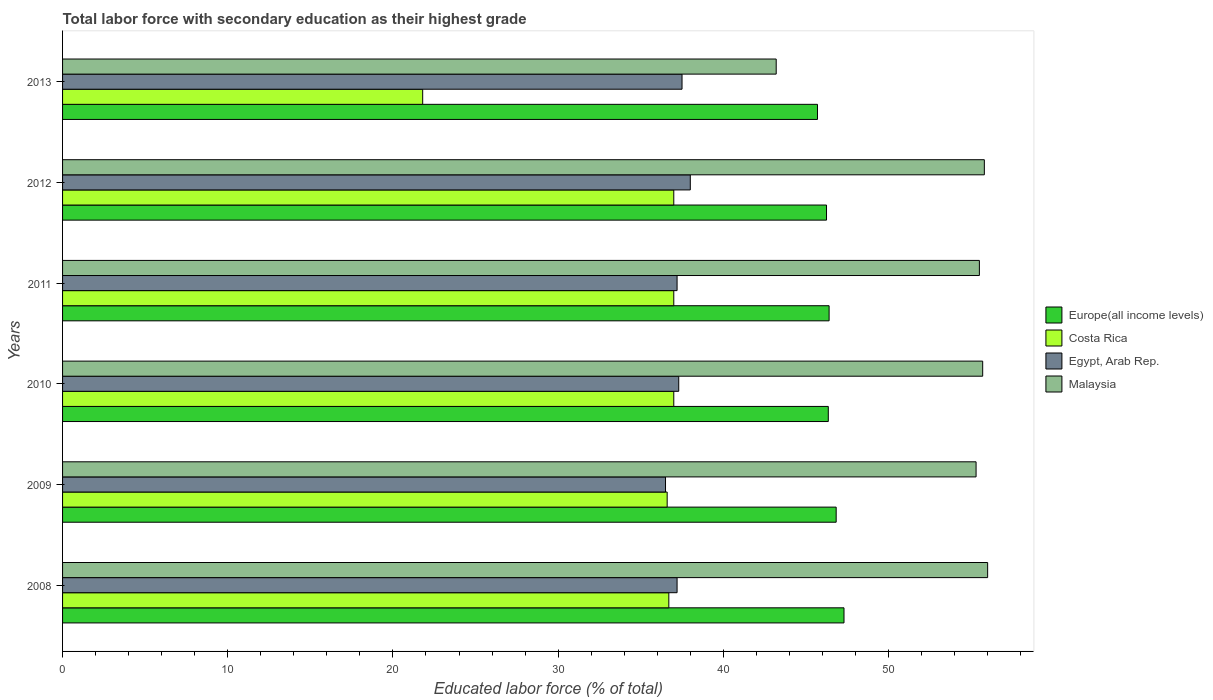How many groups of bars are there?
Your response must be concise. 6. Are the number of bars per tick equal to the number of legend labels?
Ensure brevity in your answer.  Yes. How many bars are there on the 4th tick from the top?
Your answer should be compact. 4. In how many cases, is the number of bars for a given year not equal to the number of legend labels?
Your response must be concise. 0. What is the percentage of total labor force with primary education in Egypt, Arab Rep. in 2011?
Offer a terse response. 37.2. Across all years, what is the maximum percentage of total labor force with primary education in Europe(all income levels)?
Provide a short and direct response. 47.3. Across all years, what is the minimum percentage of total labor force with primary education in Egypt, Arab Rep.?
Offer a terse response. 36.5. In which year was the percentage of total labor force with primary education in Egypt, Arab Rep. maximum?
Your answer should be very brief. 2012. In which year was the percentage of total labor force with primary education in Egypt, Arab Rep. minimum?
Your response must be concise. 2009. What is the total percentage of total labor force with primary education in Malaysia in the graph?
Offer a very short reply. 321.5. What is the difference between the percentage of total labor force with primary education in Malaysia in 2009 and the percentage of total labor force with primary education in Egypt, Arab Rep. in 2011?
Provide a succinct answer. 18.1. What is the average percentage of total labor force with primary education in Costa Rica per year?
Your response must be concise. 34.35. In the year 2010, what is the difference between the percentage of total labor force with primary education in Europe(all income levels) and percentage of total labor force with primary education in Costa Rica?
Offer a very short reply. 9.35. What is the ratio of the percentage of total labor force with primary education in Malaysia in 2008 to that in 2012?
Ensure brevity in your answer.  1. What is the difference between the highest and the second highest percentage of total labor force with primary education in Malaysia?
Your answer should be very brief. 0.2. What is the difference between the highest and the lowest percentage of total labor force with primary education in Europe(all income levels)?
Your answer should be compact. 1.61. Is the sum of the percentage of total labor force with primary education in Malaysia in 2008 and 2011 greater than the maximum percentage of total labor force with primary education in Europe(all income levels) across all years?
Keep it short and to the point. Yes. Is it the case that in every year, the sum of the percentage of total labor force with primary education in Costa Rica and percentage of total labor force with primary education in Malaysia is greater than the sum of percentage of total labor force with primary education in Egypt, Arab Rep. and percentage of total labor force with primary education in Europe(all income levels)?
Make the answer very short. No. What does the 2nd bar from the top in 2013 represents?
Your answer should be compact. Egypt, Arab Rep. What does the 4th bar from the bottom in 2010 represents?
Offer a very short reply. Malaysia. Is it the case that in every year, the sum of the percentage of total labor force with primary education in Malaysia and percentage of total labor force with primary education in Europe(all income levels) is greater than the percentage of total labor force with primary education in Egypt, Arab Rep.?
Your response must be concise. Yes. Are all the bars in the graph horizontal?
Offer a terse response. Yes. Does the graph contain any zero values?
Give a very brief answer. No. Does the graph contain grids?
Your answer should be compact. No. Where does the legend appear in the graph?
Offer a very short reply. Center right. How are the legend labels stacked?
Give a very brief answer. Vertical. What is the title of the graph?
Offer a terse response. Total labor force with secondary education as their highest grade. What is the label or title of the X-axis?
Provide a short and direct response. Educated labor force (% of total). What is the Educated labor force (% of total) in Europe(all income levels) in 2008?
Provide a short and direct response. 47.3. What is the Educated labor force (% of total) in Costa Rica in 2008?
Provide a short and direct response. 36.7. What is the Educated labor force (% of total) in Egypt, Arab Rep. in 2008?
Your response must be concise. 37.2. What is the Educated labor force (% of total) in Europe(all income levels) in 2009?
Your response must be concise. 46.83. What is the Educated labor force (% of total) of Costa Rica in 2009?
Offer a terse response. 36.6. What is the Educated labor force (% of total) of Egypt, Arab Rep. in 2009?
Offer a very short reply. 36.5. What is the Educated labor force (% of total) in Malaysia in 2009?
Your answer should be compact. 55.3. What is the Educated labor force (% of total) in Europe(all income levels) in 2010?
Keep it short and to the point. 46.35. What is the Educated labor force (% of total) of Egypt, Arab Rep. in 2010?
Your answer should be very brief. 37.3. What is the Educated labor force (% of total) of Malaysia in 2010?
Keep it short and to the point. 55.7. What is the Educated labor force (% of total) of Europe(all income levels) in 2011?
Offer a very short reply. 46.4. What is the Educated labor force (% of total) in Costa Rica in 2011?
Offer a terse response. 37. What is the Educated labor force (% of total) of Egypt, Arab Rep. in 2011?
Keep it short and to the point. 37.2. What is the Educated labor force (% of total) in Malaysia in 2011?
Ensure brevity in your answer.  55.5. What is the Educated labor force (% of total) of Europe(all income levels) in 2012?
Provide a short and direct response. 46.25. What is the Educated labor force (% of total) in Egypt, Arab Rep. in 2012?
Your response must be concise. 38. What is the Educated labor force (% of total) of Malaysia in 2012?
Offer a very short reply. 55.8. What is the Educated labor force (% of total) in Europe(all income levels) in 2013?
Give a very brief answer. 45.7. What is the Educated labor force (% of total) of Costa Rica in 2013?
Offer a very short reply. 21.8. What is the Educated labor force (% of total) of Egypt, Arab Rep. in 2013?
Ensure brevity in your answer.  37.5. What is the Educated labor force (% of total) of Malaysia in 2013?
Ensure brevity in your answer.  43.2. Across all years, what is the maximum Educated labor force (% of total) of Europe(all income levels)?
Give a very brief answer. 47.3. Across all years, what is the maximum Educated labor force (% of total) in Costa Rica?
Ensure brevity in your answer.  37. Across all years, what is the maximum Educated labor force (% of total) of Malaysia?
Provide a succinct answer. 56. Across all years, what is the minimum Educated labor force (% of total) in Europe(all income levels)?
Your answer should be compact. 45.7. Across all years, what is the minimum Educated labor force (% of total) in Costa Rica?
Provide a short and direct response. 21.8. Across all years, what is the minimum Educated labor force (% of total) in Egypt, Arab Rep.?
Ensure brevity in your answer.  36.5. Across all years, what is the minimum Educated labor force (% of total) of Malaysia?
Ensure brevity in your answer.  43.2. What is the total Educated labor force (% of total) of Europe(all income levels) in the graph?
Provide a succinct answer. 278.84. What is the total Educated labor force (% of total) in Costa Rica in the graph?
Ensure brevity in your answer.  206.1. What is the total Educated labor force (% of total) of Egypt, Arab Rep. in the graph?
Keep it short and to the point. 223.7. What is the total Educated labor force (% of total) of Malaysia in the graph?
Provide a succinct answer. 321.5. What is the difference between the Educated labor force (% of total) of Europe(all income levels) in 2008 and that in 2009?
Provide a succinct answer. 0.47. What is the difference between the Educated labor force (% of total) of Egypt, Arab Rep. in 2008 and that in 2009?
Ensure brevity in your answer.  0.7. What is the difference between the Educated labor force (% of total) of Europe(all income levels) in 2008 and that in 2010?
Give a very brief answer. 0.95. What is the difference between the Educated labor force (% of total) in Malaysia in 2008 and that in 2010?
Keep it short and to the point. 0.3. What is the difference between the Educated labor force (% of total) of Europe(all income levels) in 2008 and that in 2011?
Your response must be concise. 0.9. What is the difference between the Educated labor force (% of total) of Costa Rica in 2008 and that in 2011?
Your response must be concise. -0.3. What is the difference between the Educated labor force (% of total) in Malaysia in 2008 and that in 2011?
Offer a very short reply. 0.5. What is the difference between the Educated labor force (% of total) in Europe(all income levels) in 2008 and that in 2012?
Ensure brevity in your answer.  1.06. What is the difference between the Educated labor force (% of total) in Egypt, Arab Rep. in 2008 and that in 2012?
Offer a very short reply. -0.8. What is the difference between the Educated labor force (% of total) in Malaysia in 2008 and that in 2012?
Your answer should be compact. 0.2. What is the difference between the Educated labor force (% of total) in Europe(all income levels) in 2008 and that in 2013?
Your answer should be compact. 1.61. What is the difference between the Educated labor force (% of total) in Costa Rica in 2008 and that in 2013?
Offer a terse response. 14.9. What is the difference between the Educated labor force (% of total) of Europe(all income levels) in 2009 and that in 2010?
Ensure brevity in your answer.  0.48. What is the difference between the Educated labor force (% of total) in Europe(all income levels) in 2009 and that in 2011?
Keep it short and to the point. 0.43. What is the difference between the Educated labor force (% of total) of Costa Rica in 2009 and that in 2011?
Provide a short and direct response. -0.4. What is the difference between the Educated labor force (% of total) of Egypt, Arab Rep. in 2009 and that in 2011?
Provide a short and direct response. -0.7. What is the difference between the Educated labor force (% of total) of Europe(all income levels) in 2009 and that in 2012?
Make the answer very short. 0.58. What is the difference between the Educated labor force (% of total) of Costa Rica in 2009 and that in 2012?
Your answer should be compact. -0.4. What is the difference between the Educated labor force (% of total) in Egypt, Arab Rep. in 2009 and that in 2012?
Ensure brevity in your answer.  -1.5. What is the difference between the Educated labor force (% of total) in Europe(all income levels) in 2009 and that in 2013?
Keep it short and to the point. 1.13. What is the difference between the Educated labor force (% of total) in Europe(all income levels) in 2010 and that in 2011?
Give a very brief answer. -0.05. What is the difference between the Educated labor force (% of total) of Egypt, Arab Rep. in 2010 and that in 2011?
Provide a short and direct response. 0.1. What is the difference between the Educated labor force (% of total) of Europe(all income levels) in 2010 and that in 2012?
Ensure brevity in your answer.  0.11. What is the difference between the Educated labor force (% of total) in Costa Rica in 2010 and that in 2012?
Ensure brevity in your answer.  0. What is the difference between the Educated labor force (% of total) of Malaysia in 2010 and that in 2012?
Provide a succinct answer. -0.1. What is the difference between the Educated labor force (% of total) in Europe(all income levels) in 2010 and that in 2013?
Provide a short and direct response. 0.65. What is the difference between the Educated labor force (% of total) in Malaysia in 2010 and that in 2013?
Your answer should be compact. 12.5. What is the difference between the Educated labor force (% of total) of Europe(all income levels) in 2011 and that in 2012?
Provide a succinct answer. 0.16. What is the difference between the Educated labor force (% of total) in Egypt, Arab Rep. in 2011 and that in 2012?
Make the answer very short. -0.8. What is the difference between the Educated labor force (% of total) of Malaysia in 2011 and that in 2012?
Provide a succinct answer. -0.3. What is the difference between the Educated labor force (% of total) of Europe(all income levels) in 2011 and that in 2013?
Provide a short and direct response. 0.7. What is the difference between the Educated labor force (% of total) in Egypt, Arab Rep. in 2011 and that in 2013?
Offer a very short reply. -0.3. What is the difference between the Educated labor force (% of total) in Malaysia in 2011 and that in 2013?
Offer a very short reply. 12.3. What is the difference between the Educated labor force (% of total) in Europe(all income levels) in 2012 and that in 2013?
Give a very brief answer. 0.55. What is the difference between the Educated labor force (% of total) of Europe(all income levels) in 2008 and the Educated labor force (% of total) of Costa Rica in 2009?
Keep it short and to the point. 10.7. What is the difference between the Educated labor force (% of total) of Europe(all income levels) in 2008 and the Educated labor force (% of total) of Egypt, Arab Rep. in 2009?
Offer a terse response. 10.8. What is the difference between the Educated labor force (% of total) in Europe(all income levels) in 2008 and the Educated labor force (% of total) in Malaysia in 2009?
Ensure brevity in your answer.  -8. What is the difference between the Educated labor force (% of total) in Costa Rica in 2008 and the Educated labor force (% of total) in Egypt, Arab Rep. in 2009?
Provide a succinct answer. 0.2. What is the difference between the Educated labor force (% of total) of Costa Rica in 2008 and the Educated labor force (% of total) of Malaysia in 2009?
Your answer should be very brief. -18.6. What is the difference between the Educated labor force (% of total) in Egypt, Arab Rep. in 2008 and the Educated labor force (% of total) in Malaysia in 2009?
Your response must be concise. -18.1. What is the difference between the Educated labor force (% of total) of Europe(all income levels) in 2008 and the Educated labor force (% of total) of Costa Rica in 2010?
Provide a short and direct response. 10.3. What is the difference between the Educated labor force (% of total) in Europe(all income levels) in 2008 and the Educated labor force (% of total) in Egypt, Arab Rep. in 2010?
Make the answer very short. 10. What is the difference between the Educated labor force (% of total) in Europe(all income levels) in 2008 and the Educated labor force (% of total) in Malaysia in 2010?
Provide a succinct answer. -8.4. What is the difference between the Educated labor force (% of total) of Egypt, Arab Rep. in 2008 and the Educated labor force (% of total) of Malaysia in 2010?
Your answer should be very brief. -18.5. What is the difference between the Educated labor force (% of total) in Europe(all income levels) in 2008 and the Educated labor force (% of total) in Costa Rica in 2011?
Keep it short and to the point. 10.3. What is the difference between the Educated labor force (% of total) of Europe(all income levels) in 2008 and the Educated labor force (% of total) of Egypt, Arab Rep. in 2011?
Offer a very short reply. 10.1. What is the difference between the Educated labor force (% of total) of Europe(all income levels) in 2008 and the Educated labor force (% of total) of Malaysia in 2011?
Provide a short and direct response. -8.2. What is the difference between the Educated labor force (% of total) in Costa Rica in 2008 and the Educated labor force (% of total) in Malaysia in 2011?
Offer a terse response. -18.8. What is the difference between the Educated labor force (% of total) of Egypt, Arab Rep. in 2008 and the Educated labor force (% of total) of Malaysia in 2011?
Make the answer very short. -18.3. What is the difference between the Educated labor force (% of total) in Europe(all income levels) in 2008 and the Educated labor force (% of total) in Costa Rica in 2012?
Offer a terse response. 10.3. What is the difference between the Educated labor force (% of total) of Europe(all income levels) in 2008 and the Educated labor force (% of total) of Egypt, Arab Rep. in 2012?
Keep it short and to the point. 9.3. What is the difference between the Educated labor force (% of total) in Europe(all income levels) in 2008 and the Educated labor force (% of total) in Malaysia in 2012?
Give a very brief answer. -8.5. What is the difference between the Educated labor force (% of total) of Costa Rica in 2008 and the Educated labor force (% of total) of Egypt, Arab Rep. in 2012?
Offer a terse response. -1.3. What is the difference between the Educated labor force (% of total) of Costa Rica in 2008 and the Educated labor force (% of total) of Malaysia in 2012?
Offer a very short reply. -19.1. What is the difference between the Educated labor force (% of total) in Egypt, Arab Rep. in 2008 and the Educated labor force (% of total) in Malaysia in 2012?
Make the answer very short. -18.6. What is the difference between the Educated labor force (% of total) of Europe(all income levels) in 2008 and the Educated labor force (% of total) of Costa Rica in 2013?
Give a very brief answer. 25.5. What is the difference between the Educated labor force (% of total) in Europe(all income levels) in 2008 and the Educated labor force (% of total) in Egypt, Arab Rep. in 2013?
Provide a succinct answer. 9.8. What is the difference between the Educated labor force (% of total) in Europe(all income levels) in 2008 and the Educated labor force (% of total) in Malaysia in 2013?
Give a very brief answer. 4.1. What is the difference between the Educated labor force (% of total) of Costa Rica in 2008 and the Educated labor force (% of total) of Egypt, Arab Rep. in 2013?
Make the answer very short. -0.8. What is the difference between the Educated labor force (% of total) in Egypt, Arab Rep. in 2008 and the Educated labor force (% of total) in Malaysia in 2013?
Provide a succinct answer. -6. What is the difference between the Educated labor force (% of total) of Europe(all income levels) in 2009 and the Educated labor force (% of total) of Costa Rica in 2010?
Your answer should be compact. 9.83. What is the difference between the Educated labor force (% of total) of Europe(all income levels) in 2009 and the Educated labor force (% of total) of Egypt, Arab Rep. in 2010?
Give a very brief answer. 9.53. What is the difference between the Educated labor force (% of total) in Europe(all income levels) in 2009 and the Educated labor force (% of total) in Malaysia in 2010?
Your answer should be very brief. -8.87. What is the difference between the Educated labor force (% of total) of Costa Rica in 2009 and the Educated labor force (% of total) of Egypt, Arab Rep. in 2010?
Keep it short and to the point. -0.7. What is the difference between the Educated labor force (% of total) in Costa Rica in 2009 and the Educated labor force (% of total) in Malaysia in 2010?
Your answer should be compact. -19.1. What is the difference between the Educated labor force (% of total) in Egypt, Arab Rep. in 2009 and the Educated labor force (% of total) in Malaysia in 2010?
Provide a short and direct response. -19.2. What is the difference between the Educated labor force (% of total) of Europe(all income levels) in 2009 and the Educated labor force (% of total) of Costa Rica in 2011?
Keep it short and to the point. 9.83. What is the difference between the Educated labor force (% of total) in Europe(all income levels) in 2009 and the Educated labor force (% of total) in Egypt, Arab Rep. in 2011?
Offer a terse response. 9.63. What is the difference between the Educated labor force (% of total) of Europe(all income levels) in 2009 and the Educated labor force (% of total) of Malaysia in 2011?
Give a very brief answer. -8.67. What is the difference between the Educated labor force (% of total) of Costa Rica in 2009 and the Educated labor force (% of total) of Egypt, Arab Rep. in 2011?
Offer a terse response. -0.6. What is the difference between the Educated labor force (% of total) in Costa Rica in 2009 and the Educated labor force (% of total) in Malaysia in 2011?
Make the answer very short. -18.9. What is the difference between the Educated labor force (% of total) of Europe(all income levels) in 2009 and the Educated labor force (% of total) of Costa Rica in 2012?
Give a very brief answer. 9.83. What is the difference between the Educated labor force (% of total) of Europe(all income levels) in 2009 and the Educated labor force (% of total) of Egypt, Arab Rep. in 2012?
Your answer should be compact. 8.83. What is the difference between the Educated labor force (% of total) in Europe(all income levels) in 2009 and the Educated labor force (% of total) in Malaysia in 2012?
Provide a short and direct response. -8.97. What is the difference between the Educated labor force (% of total) of Costa Rica in 2009 and the Educated labor force (% of total) of Malaysia in 2012?
Ensure brevity in your answer.  -19.2. What is the difference between the Educated labor force (% of total) of Egypt, Arab Rep. in 2009 and the Educated labor force (% of total) of Malaysia in 2012?
Your response must be concise. -19.3. What is the difference between the Educated labor force (% of total) of Europe(all income levels) in 2009 and the Educated labor force (% of total) of Costa Rica in 2013?
Your response must be concise. 25.03. What is the difference between the Educated labor force (% of total) of Europe(all income levels) in 2009 and the Educated labor force (% of total) of Egypt, Arab Rep. in 2013?
Provide a short and direct response. 9.33. What is the difference between the Educated labor force (% of total) of Europe(all income levels) in 2009 and the Educated labor force (% of total) of Malaysia in 2013?
Provide a short and direct response. 3.63. What is the difference between the Educated labor force (% of total) in Europe(all income levels) in 2010 and the Educated labor force (% of total) in Costa Rica in 2011?
Keep it short and to the point. 9.35. What is the difference between the Educated labor force (% of total) of Europe(all income levels) in 2010 and the Educated labor force (% of total) of Egypt, Arab Rep. in 2011?
Ensure brevity in your answer.  9.15. What is the difference between the Educated labor force (% of total) of Europe(all income levels) in 2010 and the Educated labor force (% of total) of Malaysia in 2011?
Your answer should be compact. -9.15. What is the difference between the Educated labor force (% of total) of Costa Rica in 2010 and the Educated labor force (% of total) of Malaysia in 2011?
Your response must be concise. -18.5. What is the difference between the Educated labor force (% of total) in Egypt, Arab Rep. in 2010 and the Educated labor force (% of total) in Malaysia in 2011?
Your answer should be very brief. -18.2. What is the difference between the Educated labor force (% of total) of Europe(all income levels) in 2010 and the Educated labor force (% of total) of Costa Rica in 2012?
Your answer should be compact. 9.35. What is the difference between the Educated labor force (% of total) in Europe(all income levels) in 2010 and the Educated labor force (% of total) in Egypt, Arab Rep. in 2012?
Your response must be concise. 8.35. What is the difference between the Educated labor force (% of total) of Europe(all income levels) in 2010 and the Educated labor force (% of total) of Malaysia in 2012?
Your answer should be compact. -9.45. What is the difference between the Educated labor force (% of total) in Costa Rica in 2010 and the Educated labor force (% of total) in Egypt, Arab Rep. in 2012?
Your response must be concise. -1. What is the difference between the Educated labor force (% of total) in Costa Rica in 2010 and the Educated labor force (% of total) in Malaysia in 2012?
Your answer should be compact. -18.8. What is the difference between the Educated labor force (% of total) in Egypt, Arab Rep. in 2010 and the Educated labor force (% of total) in Malaysia in 2012?
Your answer should be very brief. -18.5. What is the difference between the Educated labor force (% of total) of Europe(all income levels) in 2010 and the Educated labor force (% of total) of Costa Rica in 2013?
Provide a short and direct response. 24.55. What is the difference between the Educated labor force (% of total) of Europe(all income levels) in 2010 and the Educated labor force (% of total) of Egypt, Arab Rep. in 2013?
Provide a short and direct response. 8.85. What is the difference between the Educated labor force (% of total) in Europe(all income levels) in 2010 and the Educated labor force (% of total) in Malaysia in 2013?
Give a very brief answer. 3.15. What is the difference between the Educated labor force (% of total) in Costa Rica in 2010 and the Educated labor force (% of total) in Egypt, Arab Rep. in 2013?
Offer a very short reply. -0.5. What is the difference between the Educated labor force (% of total) of Costa Rica in 2010 and the Educated labor force (% of total) of Malaysia in 2013?
Provide a succinct answer. -6.2. What is the difference between the Educated labor force (% of total) of Egypt, Arab Rep. in 2010 and the Educated labor force (% of total) of Malaysia in 2013?
Keep it short and to the point. -5.9. What is the difference between the Educated labor force (% of total) of Europe(all income levels) in 2011 and the Educated labor force (% of total) of Costa Rica in 2012?
Make the answer very short. 9.4. What is the difference between the Educated labor force (% of total) in Europe(all income levels) in 2011 and the Educated labor force (% of total) in Egypt, Arab Rep. in 2012?
Offer a terse response. 8.4. What is the difference between the Educated labor force (% of total) of Europe(all income levels) in 2011 and the Educated labor force (% of total) of Malaysia in 2012?
Offer a very short reply. -9.4. What is the difference between the Educated labor force (% of total) in Costa Rica in 2011 and the Educated labor force (% of total) in Egypt, Arab Rep. in 2012?
Give a very brief answer. -1. What is the difference between the Educated labor force (% of total) of Costa Rica in 2011 and the Educated labor force (% of total) of Malaysia in 2012?
Your answer should be compact. -18.8. What is the difference between the Educated labor force (% of total) of Egypt, Arab Rep. in 2011 and the Educated labor force (% of total) of Malaysia in 2012?
Offer a very short reply. -18.6. What is the difference between the Educated labor force (% of total) of Europe(all income levels) in 2011 and the Educated labor force (% of total) of Costa Rica in 2013?
Offer a terse response. 24.6. What is the difference between the Educated labor force (% of total) of Europe(all income levels) in 2011 and the Educated labor force (% of total) of Egypt, Arab Rep. in 2013?
Keep it short and to the point. 8.9. What is the difference between the Educated labor force (% of total) in Europe(all income levels) in 2011 and the Educated labor force (% of total) in Malaysia in 2013?
Offer a very short reply. 3.2. What is the difference between the Educated labor force (% of total) of Europe(all income levels) in 2012 and the Educated labor force (% of total) of Costa Rica in 2013?
Your answer should be very brief. 24.45. What is the difference between the Educated labor force (% of total) in Europe(all income levels) in 2012 and the Educated labor force (% of total) in Egypt, Arab Rep. in 2013?
Ensure brevity in your answer.  8.75. What is the difference between the Educated labor force (% of total) in Europe(all income levels) in 2012 and the Educated labor force (% of total) in Malaysia in 2013?
Keep it short and to the point. 3.05. What is the difference between the Educated labor force (% of total) of Costa Rica in 2012 and the Educated labor force (% of total) of Egypt, Arab Rep. in 2013?
Ensure brevity in your answer.  -0.5. What is the difference between the Educated labor force (% of total) in Egypt, Arab Rep. in 2012 and the Educated labor force (% of total) in Malaysia in 2013?
Offer a terse response. -5.2. What is the average Educated labor force (% of total) in Europe(all income levels) per year?
Keep it short and to the point. 46.47. What is the average Educated labor force (% of total) in Costa Rica per year?
Your response must be concise. 34.35. What is the average Educated labor force (% of total) in Egypt, Arab Rep. per year?
Give a very brief answer. 37.28. What is the average Educated labor force (% of total) in Malaysia per year?
Your answer should be compact. 53.58. In the year 2008, what is the difference between the Educated labor force (% of total) of Europe(all income levels) and Educated labor force (% of total) of Costa Rica?
Keep it short and to the point. 10.6. In the year 2008, what is the difference between the Educated labor force (% of total) in Europe(all income levels) and Educated labor force (% of total) in Egypt, Arab Rep.?
Your answer should be compact. 10.1. In the year 2008, what is the difference between the Educated labor force (% of total) of Europe(all income levels) and Educated labor force (% of total) of Malaysia?
Provide a short and direct response. -8.7. In the year 2008, what is the difference between the Educated labor force (% of total) in Costa Rica and Educated labor force (% of total) in Egypt, Arab Rep.?
Ensure brevity in your answer.  -0.5. In the year 2008, what is the difference between the Educated labor force (% of total) of Costa Rica and Educated labor force (% of total) of Malaysia?
Ensure brevity in your answer.  -19.3. In the year 2008, what is the difference between the Educated labor force (% of total) in Egypt, Arab Rep. and Educated labor force (% of total) in Malaysia?
Ensure brevity in your answer.  -18.8. In the year 2009, what is the difference between the Educated labor force (% of total) of Europe(all income levels) and Educated labor force (% of total) of Costa Rica?
Offer a very short reply. 10.23. In the year 2009, what is the difference between the Educated labor force (% of total) in Europe(all income levels) and Educated labor force (% of total) in Egypt, Arab Rep.?
Provide a short and direct response. 10.33. In the year 2009, what is the difference between the Educated labor force (% of total) in Europe(all income levels) and Educated labor force (% of total) in Malaysia?
Make the answer very short. -8.47. In the year 2009, what is the difference between the Educated labor force (% of total) of Costa Rica and Educated labor force (% of total) of Egypt, Arab Rep.?
Your answer should be very brief. 0.1. In the year 2009, what is the difference between the Educated labor force (% of total) of Costa Rica and Educated labor force (% of total) of Malaysia?
Provide a succinct answer. -18.7. In the year 2009, what is the difference between the Educated labor force (% of total) of Egypt, Arab Rep. and Educated labor force (% of total) of Malaysia?
Make the answer very short. -18.8. In the year 2010, what is the difference between the Educated labor force (% of total) of Europe(all income levels) and Educated labor force (% of total) of Costa Rica?
Provide a short and direct response. 9.35. In the year 2010, what is the difference between the Educated labor force (% of total) in Europe(all income levels) and Educated labor force (% of total) in Egypt, Arab Rep.?
Give a very brief answer. 9.05. In the year 2010, what is the difference between the Educated labor force (% of total) of Europe(all income levels) and Educated labor force (% of total) of Malaysia?
Provide a short and direct response. -9.35. In the year 2010, what is the difference between the Educated labor force (% of total) in Costa Rica and Educated labor force (% of total) in Malaysia?
Offer a terse response. -18.7. In the year 2010, what is the difference between the Educated labor force (% of total) of Egypt, Arab Rep. and Educated labor force (% of total) of Malaysia?
Offer a terse response. -18.4. In the year 2011, what is the difference between the Educated labor force (% of total) in Europe(all income levels) and Educated labor force (% of total) in Costa Rica?
Give a very brief answer. 9.4. In the year 2011, what is the difference between the Educated labor force (% of total) in Europe(all income levels) and Educated labor force (% of total) in Egypt, Arab Rep.?
Make the answer very short. 9.2. In the year 2011, what is the difference between the Educated labor force (% of total) in Europe(all income levels) and Educated labor force (% of total) in Malaysia?
Offer a terse response. -9.1. In the year 2011, what is the difference between the Educated labor force (% of total) of Costa Rica and Educated labor force (% of total) of Malaysia?
Offer a terse response. -18.5. In the year 2011, what is the difference between the Educated labor force (% of total) in Egypt, Arab Rep. and Educated labor force (% of total) in Malaysia?
Ensure brevity in your answer.  -18.3. In the year 2012, what is the difference between the Educated labor force (% of total) in Europe(all income levels) and Educated labor force (% of total) in Costa Rica?
Your response must be concise. 9.25. In the year 2012, what is the difference between the Educated labor force (% of total) of Europe(all income levels) and Educated labor force (% of total) of Egypt, Arab Rep.?
Make the answer very short. 8.25. In the year 2012, what is the difference between the Educated labor force (% of total) in Europe(all income levels) and Educated labor force (% of total) in Malaysia?
Your answer should be compact. -9.55. In the year 2012, what is the difference between the Educated labor force (% of total) in Costa Rica and Educated labor force (% of total) in Egypt, Arab Rep.?
Your answer should be very brief. -1. In the year 2012, what is the difference between the Educated labor force (% of total) in Costa Rica and Educated labor force (% of total) in Malaysia?
Provide a succinct answer. -18.8. In the year 2012, what is the difference between the Educated labor force (% of total) of Egypt, Arab Rep. and Educated labor force (% of total) of Malaysia?
Provide a short and direct response. -17.8. In the year 2013, what is the difference between the Educated labor force (% of total) of Europe(all income levels) and Educated labor force (% of total) of Costa Rica?
Offer a very short reply. 23.9. In the year 2013, what is the difference between the Educated labor force (% of total) of Europe(all income levels) and Educated labor force (% of total) of Egypt, Arab Rep.?
Your answer should be very brief. 8.2. In the year 2013, what is the difference between the Educated labor force (% of total) in Europe(all income levels) and Educated labor force (% of total) in Malaysia?
Offer a very short reply. 2.5. In the year 2013, what is the difference between the Educated labor force (% of total) of Costa Rica and Educated labor force (% of total) of Egypt, Arab Rep.?
Make the answer very short. -15.7. In the year 2013, what is the difference between the Educated labor force (% of total) of Costa Rica and Educated labor force (% of total) of Malaysia?
Your response must be concise. -21.4. What is the ratio of the Educated labor force (% of total) of Egypt, Arab Rep. in 2008 to that in 2009?
Keep it short and to the point. 1.02. What is the ratio of the Educated labor force (% of total) in Malaysia in 2008 to that in 2009?
Give a very brief answer. 1.01. What is the ratio of the Educated labor force (% of total) of Europe(all income levels) in 2008 to that in 2010?
Provide a succinct answer. 1.02. What is the ratio of the Educated labor force (% of total) of Egypt, Arab Rep. in 2008 to that in 2010?
Provide a short and direct response. 1. What is the ratio of the Educated labor force (% of total) of Malaysia in 2008 to that in 2010?
Your answer should be very brief. 1.01. What is the ratio of the Educated labor force (% of total) of Europe(all income levels) in 2008 to that in 2011?
Make the answer very short. 1.02. What is the ratio of the Educated labor force (% of total) in Costa Rica in 2008 to that in 2011?
Provide a succinct answer. 0.99. What is the ratio of the Educated labor force (% of total) of Malaysia in 2008 to that in 2011?
Your response must be concise. 1.01. What is the ratio of the Educated labor force (% of total) of Europe(all income levels) in 2008 to that in 2012?
Ensure brevity in your answer.  1.02. What is the ratio of the Educated labor force (% of total) of Costa Rica in 2008 to that in 2012?
Offer a very short reply. 0.99. What is the ratio of the Educated labor force (% of total) in Egypt, Arab Rep. in 2008 to that in 2012?
Provide a short and direct response. 0.98. What is the ratio of the Educated labor force (% of total) of Europe(all income levels) in 2008 to that in 2013?
Give a very brief answer. 1.04. What is the ratio of the Educated labor force (% of total) of Costa Rica in 2008 to that in 2013?
Your response must be concise. 1.68. What is the ratio of the Educated labor force (% of total) in Malaysia in 2008 to that in 2013?
Your answer should be compact. 1.3. What is the ratio of the Educated labor force (% of total) in Europe(all income levels) in 2009 to that in 2010?
Keep it short and to the point. 1.01. What is the ratio of the Educated labor force (% of total) of Egypt, Arab Rep. in 2009 to that in 2010?
Offer a terse response. 0.98. What is the ratio of the Educated labor force (% of total) in Europe(all income levels) in 2009 to that in 2011?
Make the answer very short. 1.01. What is the ratio of the Educated labor force (% of total) in Costa Rica in 2009 to that in 2011?
Your answer should be compact. 0.99. What is the ratio of the Educated labor force (% of total) of Egypt, Arab Rep. in 2009 to that in 2011?
Offer a terse response. 0.98. What is the ratio of the Educated labor force (% of total) in Europe(all income levels) in 2009 to that in 2012?
Offer a very short reply. 1.01. What is the ratio of the Educated labor force (% of total) in Egypt, Arab Rep. in 2009 to that in 2012?
Make the answer very short. 0.96. What is the ratio of the Educated labor force (% of total) of Europe(all income levels) in 2009 to that in 2013?
Give a very brief answer. 1.02. What is the ratio of the Educated labor force (% of total) of Costa Rica in 2009 to that in 2013?
Keep it short and to the point. 1.68. What is the ratio of the Educated labor force (% of total) in Egypt, Arab Rep. in 2009 to that in 2013?
Ensure brevity in your answer.  0.97. What is the ratio of the Educated labor force (% of total) of Malaysia in 2009 to that in 2013?
Make the answer very short. 1.28. What is the ratio of the Educated labor force (% of total) in Costa Rica in 2010 to that in 2011?
Make the answer very short. 1. What is the ratio of the Educated labor force (% of total) in Egypt, Arab Rep. in 2010 to that in 2011?
Give a very brief answer. 1. What is the ratio of the Educated labor force (% of total) in Europe(all income levels) in 2010 to that in 2012?
Offer a very short reply. 1. What is the ratio of the Educated labor force (% of total) in Egypt, Arab Rep. in 2010 to that in 2012?
Your answer should be compact. 0.98. What is the ratio of the Educated labor force (% of total) in Europe(all income levels) in 2010 to that in 2013?
Make the answer very short. 1.01. What is the ratio of the Educated labor force (% of total) of Costa Rica in 2010 to that in 2013?
Provide a succinct answer. 1.7. What is the ratio of the Educated labor force (% of total) of Malaysia in 2010 to that in 2013?
Your response must be concise. 1.29. What is the ratio of the Educated labor force (% of total) of Europe(all income levels) in 2011 to that in 2012?
Your response must be concise. 1. What is the ratio of the Educated labor force (% of total) of Costa Rica in 2011 to that in 2012?
Keep it short and to the point. 1. What is the ratio of the Educated labor force (% of total) in Egypt, Arab Rep. in 2011 to that in 2012?
Ensure brevity in your answer.  0.98. What is the ratio of the Educated labor force (% of total) of Malaysia in 2011 to that in 2012?
Give a very brief answer. 0.99. What is the ratio of the Educated labor force (% of total) of Europe(all income levels) in 2011 to that in 2013?
Your answer should be very brief. 1.02. What is the ratio of the Educated labor force (% of total) of Costa Rica in 2011 to that in 2013?
Offer a terse response. 1.7. What is the ratio of the Educated labor force (% of total) of Egypt, Arab Rep. in 2011 to that in 2013?
Offer a terse response. 0.99. What is the ratio of the Educated labor force (% of total) of Malaysia in 2011 to that in 2013?
Your answer should be compact. 1.28. What is the ratio of the Educated labor force (% of total) in Europe(all income levels) in 2012 to that in 2013?
Keep it short and to the point. 1.01. What is the ratio of the Educated labor force (% of total) of Costa Rica in 2012 to that in 2013?
Offer a terse response. 1.7. What is the ratio of the Educated labor force (% of total) in Egypt, Arab Rep. in 2012 to that in 2013?
Give a very brief answer. 1.01. What is the ratio of the Educated labor force (% of total) in Malaysia in 2012 to that in 2013?
Your answer should be compact. 1.29. What is the difference between the highest and the second highest Educated labor force (% of total) of Europe(all income levels)?
Provide a short and direct response. 0.47. What is the difference between the highest and the second highest Educated labor force (% of total) of Costa Rica?
Offer a very short reply. 0. What is the difference between the highest and the second highest Educated labor force (% of total) of Malaysia?
Provide a short and direct response. 0.2. What is the difference between the highest and the lowest Educated labor force (% of total) of Europe(all income levels)?
Provide a short and direct response. 1.61. What is the difference between the highest and the lowest Educated labor force (% of total) in Costa Rica?
Your answer should be compact. 15.2. What is the difference between the highest and the lowest Educated labor force (% of total) of Egypt, Arab Rep.?
Make the answer very short. 1.5. What is the difference between the highest and the lowest Educated labor force (% of total) in Malaysia?
Offer a terse response. 12.8. 